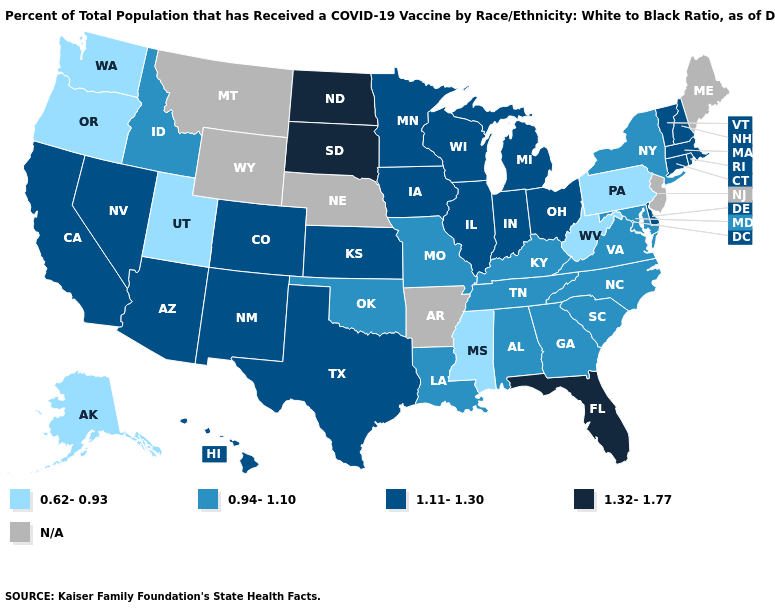Which states have the highest value in the USA?
Answer briefly. Florida, North Dakota, South Dakota. Does Indiana have the lowest value in the USA?
Be succinct. No. What is the highest value in the West ?
Quick response, please. 1.11-1.30. What is the value of South Carolina?
Give a very brief answer. 0.94-1.10. What is the value of New York?
Keep it brief. 0.94-1.10. Among the states that border Missouri , does Illinois have the highest value?
Answer briefly. Yes. What is the lowest value in the USA?
Write a very short answer. 0.62-0.93. Name the states that have a value in the range 1.32-1.77?
Give a very brief answer. Florida, North Dakota, South Dakota. Which states hav the highest value in the South?
Be succinct. Florida. What is the value of Maryland?
Quick response, please. 0.94-1.10. Does the map have missing data?
Quick response, please. Yes. Among the states that border Massachusetts , does New York have the highest value?
Quick response, please. No. Does the map have missing data?
Short answer required. Yes. Name the states that have a value in the range 1.11-1.30?
Answer briefly. Arizona, California, Colorado, Connecticut, Delaware, Hawaii, Illinois, Indiana, Iowa, Kansas, Massachusetts, Michigan, Minnesota, Nevada, New Hampshire, New Mexico, Ohio, Rhode Island, Texas, Vermont, Wisconsin. 